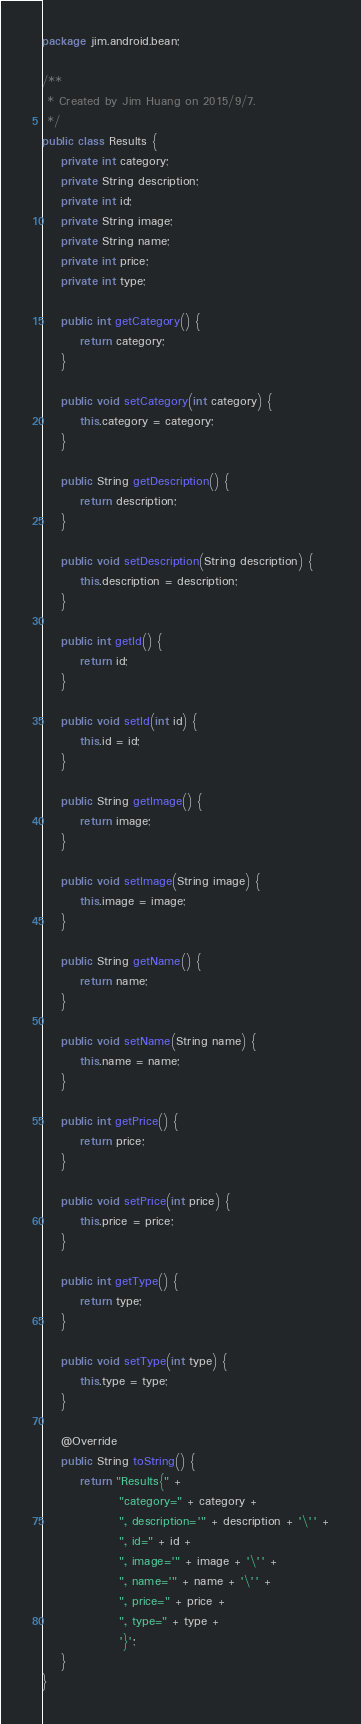<code> <loc_0><loc_0><loc_500><loc_500><_Java_>package jim.android.bean;

/**
 * Created by Jim Huang on 2015/9/7.
 */
public class Results {
    private int category;
    private String description;
    private int id;
    private String image;
    private String name;
    private int price;
    private int type;

    public int getCategory() {
        return category;
    }

    public void setCategory(int category) {
        this.category = category;
    }

    public String getDescription() {
        return description;
    }

    public void setDescription(String description) {
        this.description = description;
    }

    public int getId() {
        return id;
    }

    public void setId(int id) {
        this.id = id;
    }

    public String getImage() {
        return image;
    }

    public void setImage(String image) {
        this.image = image;
    }

    public String getName() {
        return name;
    }

    public void setName(String name) {
        this.name = name;
    }

    public int getPrice() {
        return price;
    }

    public void setPrice(int price) {
        this.price = price;
    }

    public int getType() {
        return type;
    }

    public void setType(int type) {
        this.type = type;
    }

    @Override
    public String toString() {
        return "Results{" +
                "category=" + category +
                ", description='" + description + '\'' +
                ", id=" + id +
                ", image='" + image + '\'' +
                ", name='" + name + '\'' +
                ", price=" + price +
                ", type=" + type +
                '}';
    }
}
</code> 